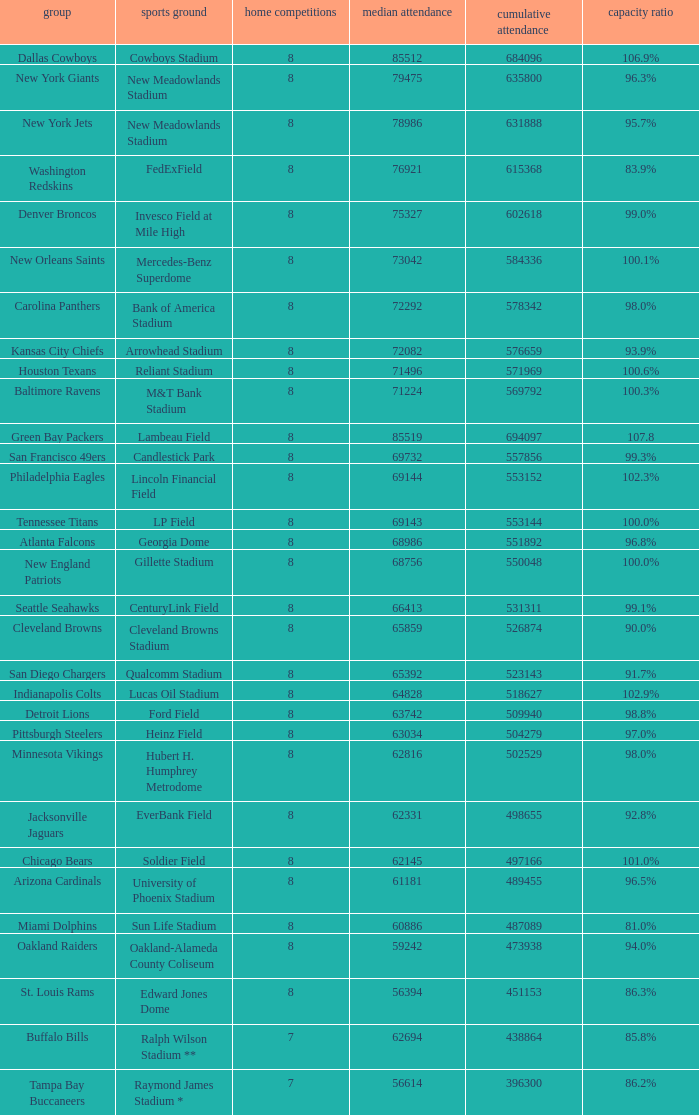How many home games are listed when the average attendance is 79475? 1.0. 